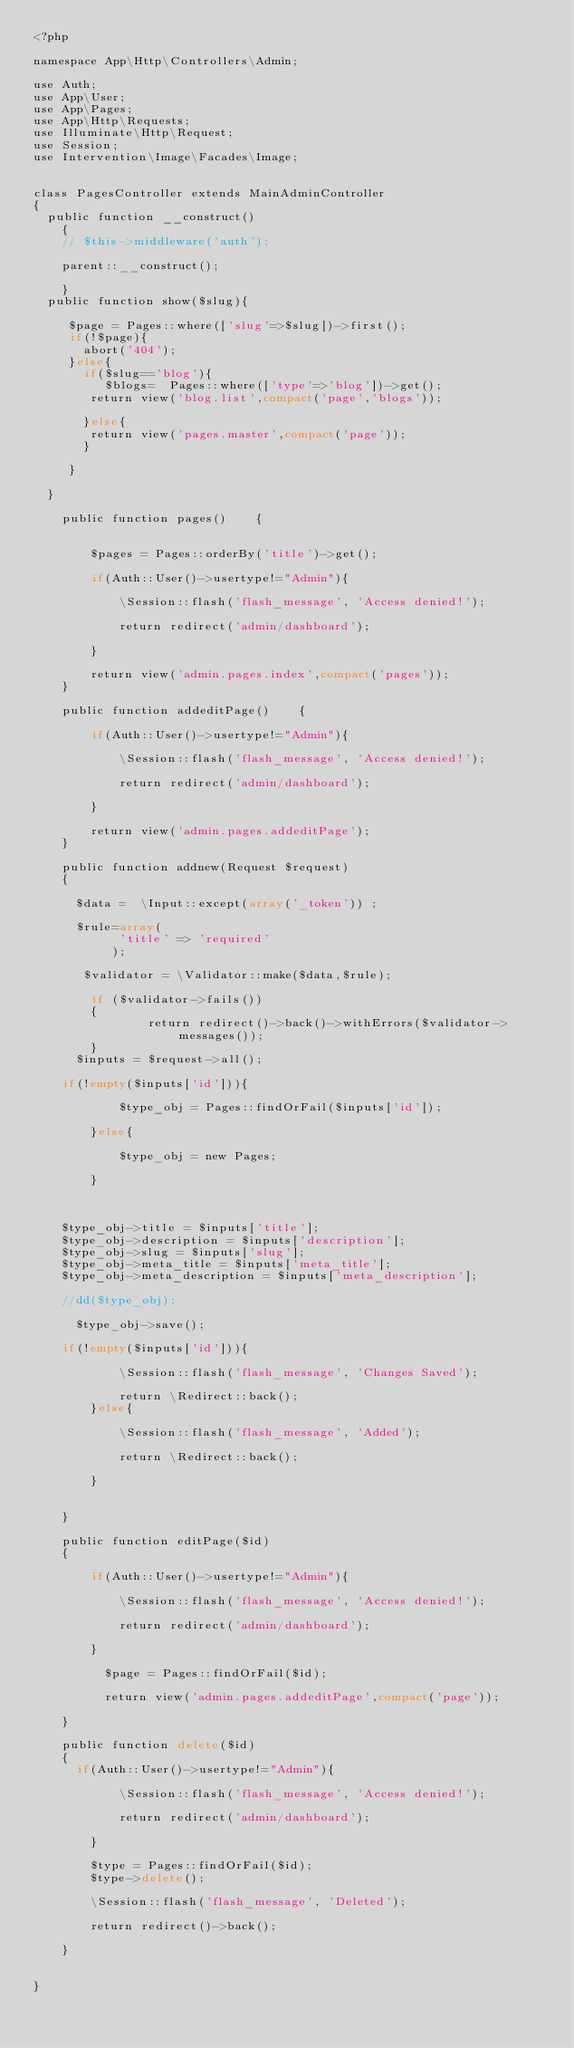Convert code to text. <code><loc_0><loc_0><loc_500><loc_500><_PHP_><?php

namespace App\Http\Controllers\Admin;

use Auth;
use App\User;
use App\Pages;
use App\Http\Requests;
use Illuminate\Http\Request;
use Session;
use Intervention\Image\Facades\Image; 


class PagesController extends MainAdminController
{
	public function __construct()
    {
		// $this->middleware('auth');
		  
		parent::__construct(); 	
		  
    }
	public function show($slug){
		
		 $page = Pages::where(['slug'=>$slug])->first();
		 if(!$page){
			 abort('404');
		 }else{
			 if($slug=='blog'){
			    $blogs=	 Pages::where(['type'=>'blog'])->get();
				return view('blog.list',compact('page','blogs'));  
				
			 }else{
				return view('pages.master',compact('page')); 				 
			 }
			 
		 }
		
	}
	
    public function pages()    { 
        
              
        $pages = Pages::orderBy('title')->get();
        
        if(Auth::User()->usertype!="Admin"){

            \Session::flash('flash_message', 'Access denied!');

            return redirect('admin/dashboard');
            
        }
         
        return view('admin.pages.index',compact('pages'));
    }
    
    public function addeditPage()    { 
         
        if(Auth::User()->usertype!="Admin"){

            \Session::flash('flash_message', 'Access denied!');

            return redirect('admin/dashboard');
            
        }
        
        return view('admin.pages.addeditPage');
    }
    
    public function addnew(Request $request)
    { 
    	
    	$data =  \Input::except(array('_token')) ;
	    
	    $rule=array(
		        'title' => 'required'		         
		   		 );
	    
	   	 $validator = \Validator::make($data,$rule);
 
        if ($validator->fails())
        {
                return redirect()->back()->withErrors($validator->messages());
        } 
	    $inputs = $request->all();
		
		if(!empty($inputs['id'])){
           
            $type_obj = Pages::findOrFail($inputs['id']);

        }else{

            $type_obj = new Pages;

        }


		
		$type_obj->title = $inputs['title']; 
		$type_obj->description = $inputs['description']; 
		$type_obj->slug = $inputs['slug']; 
		$type_obj->meta_title = $inputs['meta_title']; 
		$type_obj->meta_description = $inputs['meta_description']; 
		 
		//dd($type_obj);
		 
	    $type_obj->save();
		
		if(!empty($inputs['id'])){

            \Session::flash('flash_message', 'Changes Saved');

            return \Redirect::back();
        }else{

            \Session::flash('flash_message', 'Added');

            return \Redirect::back();

        }		     
        
         
    }     
    
    public function editPage($id)    
    {     
    
    	  if(Auth::User()->usertype!="Admin"){

            \Session::flash('flash_message', 'Access denied!');

            return redirect('admin/dashboard');
            
        }
        	     
          $page = Pages::findOrFail($id);
          
          return view('admin.pages.addeditPage',compact('page'));
        
    }	 
    
    public function delete($id)
    {
    	if(Auth::User()->usertype!="Admin"){

            \Session::flash('flash_message', 'Access denied!');

            return redirect('admin/dashboard');
            
        }
        	
        $type = Pages::findOrFail($id);
        $type->delete();

        \Session::flash('flash_message', 'Deleted');

        return redirect()->back();

    }
     
    	
}
</code> 